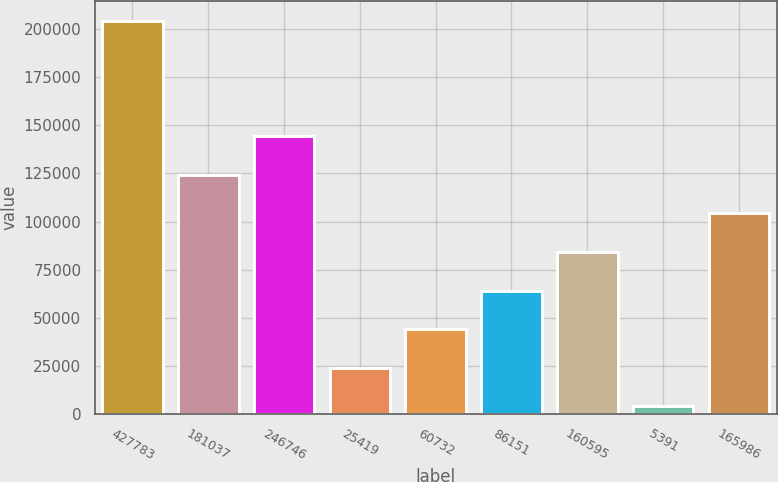Convert chart. <chart><loc_0><loc_0><loc_500><loc_500><bar_chart><fcel>427783<fcel>181037<fcel>246746<fcel>25419<fcel>60732<fcel>86151<fcel>160595<fcel>5391<fcel>165986<nl><fcel>204477<fcel>124255<fcel>144310<fcel>23976.6<fcel>44032.2<fcel>64087.8<fcel>84143.4<fcel>3921<fcel>104199<nl></chart> 